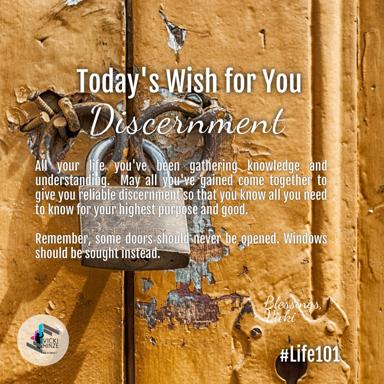What advice does the text offer about doors and windows in relation to discernment? The text advises thoughtful discernment in choosing life paths: suggesting to avoid opening some metaphorical 'doors'—or avoiding certain decisions and pathways that might seem tempting but are ultimately not beneficial. Instead, it promotes looking for 'windows,' alternative opportunities or methods, suggesting a more cautious and considered approach to decisions and life choices. 